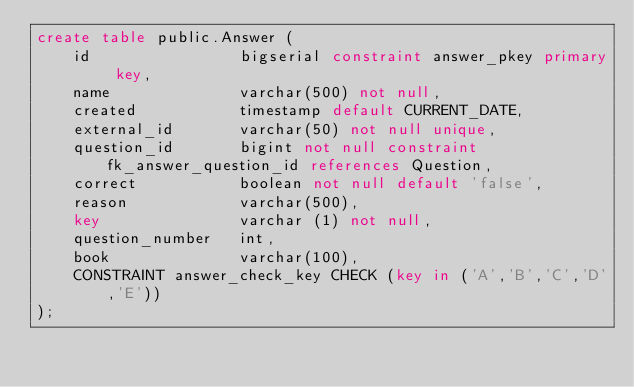<code> <loc_0><loc_0><loc_500><loc_500><_SQL_>create table public.Answer (
    id                bigserial constraint answer_pkey primary key,
    name              varchar(500) not null,
    created           timestamp default CURRENT_DATE,
    external_id       varchar(50) not null unique,
    question_id       bigint not null constraint fk_answer_question_id references Question,
    correct           boolean not null default 'false',
    reason            varchar(500),
    key               varchar (1) not null,
    question_number   int,
    book              varchar(100),
    CONSTRAINT answer_check_key CHECK (key in ('A','B','C','D','E'))
);
</code> 